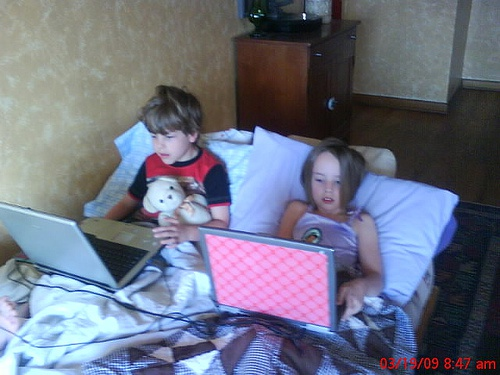Describe the objects in this image and their specific colors. I can see bed in darkgray, lightblue, and gray tones, laptop in darkgray, violet, and gray tones, people in darkgray, black, gray, and navy tones, people in darkgray, gray, and black tones, and laptop in darkgray, lightblue, gray, and black tones in this image. 